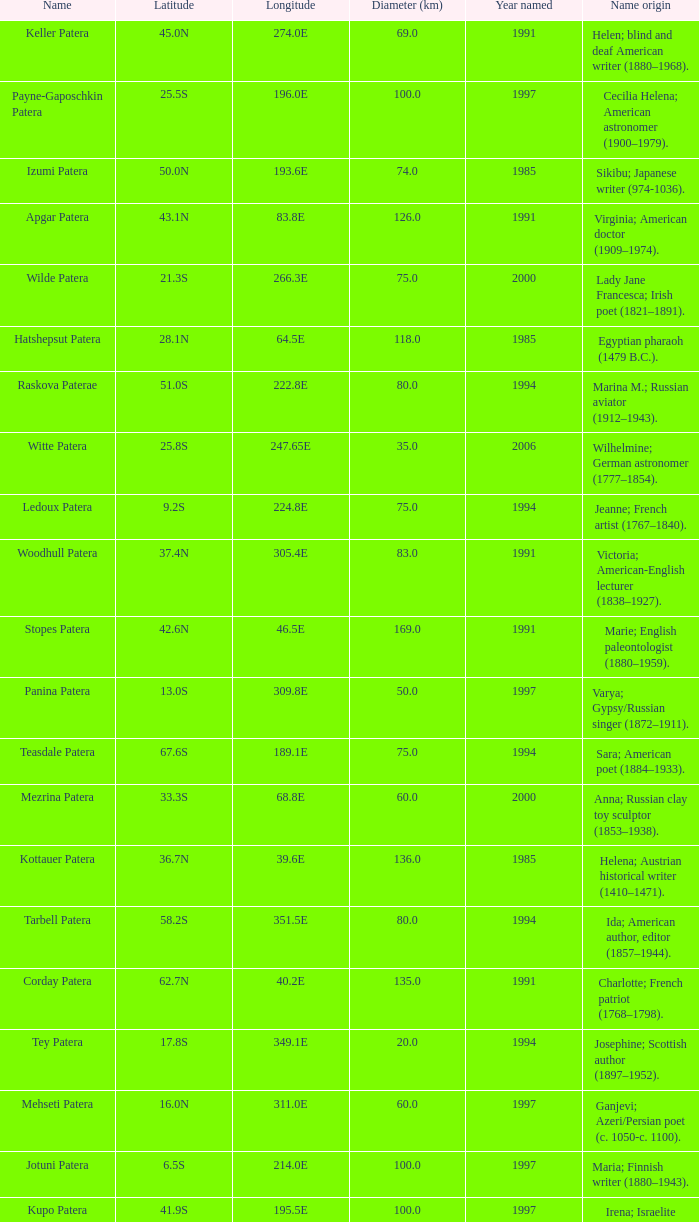What is  the diameter in km of the feature with a longitude of 40.2E?  135.0. 